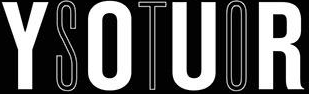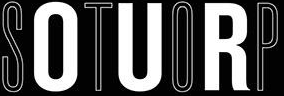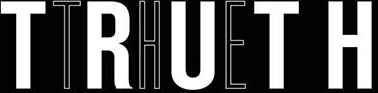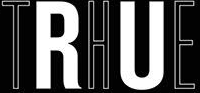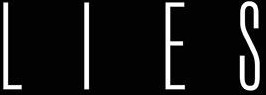What words can you see in these images in sequence, separated by a semicolon? YOUR; STOP; TRUTH; THE; LIES 